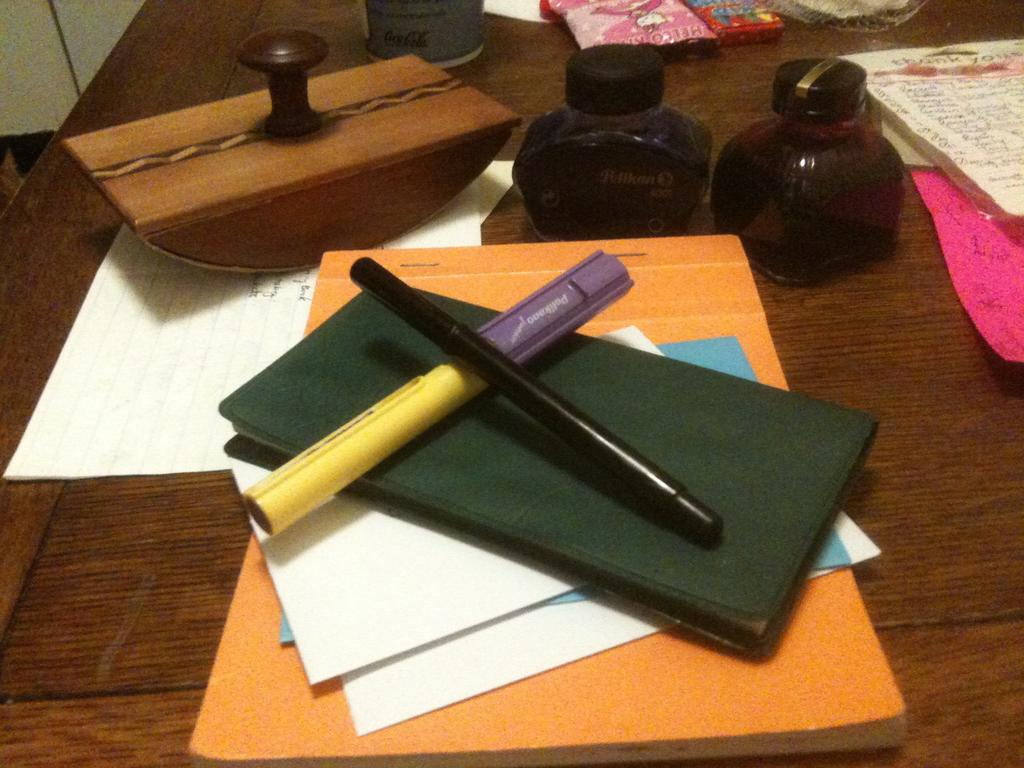What writing instruments are visible in the image? There is a pen and a marker in the image. What personal item can be seen in the image? There is a wallet in the image. What type of documents are present in the image? There are papers on a file in the image. What object is used for marking or stamping in the image? There is a rubber stamp on a paper in the image. What can be seen in the background of the image? There are bottles and a few other objects in the background of the image. What type of game is being played in the image? There is no game being played in the image. How is the string used in the image? There is no string present in the image. 